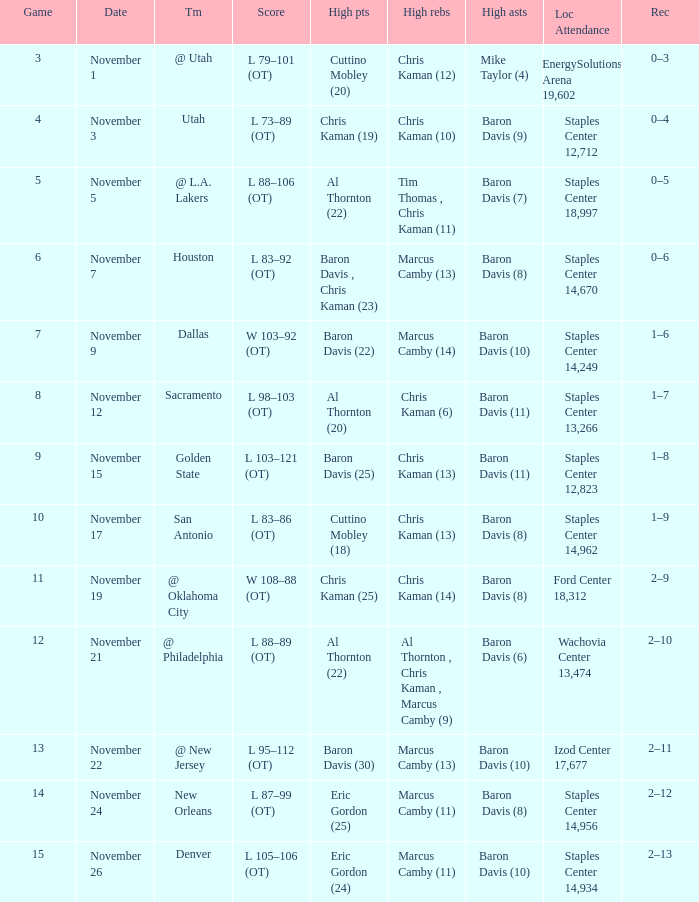Name the total number of score for staples center 13,266 1.0. 